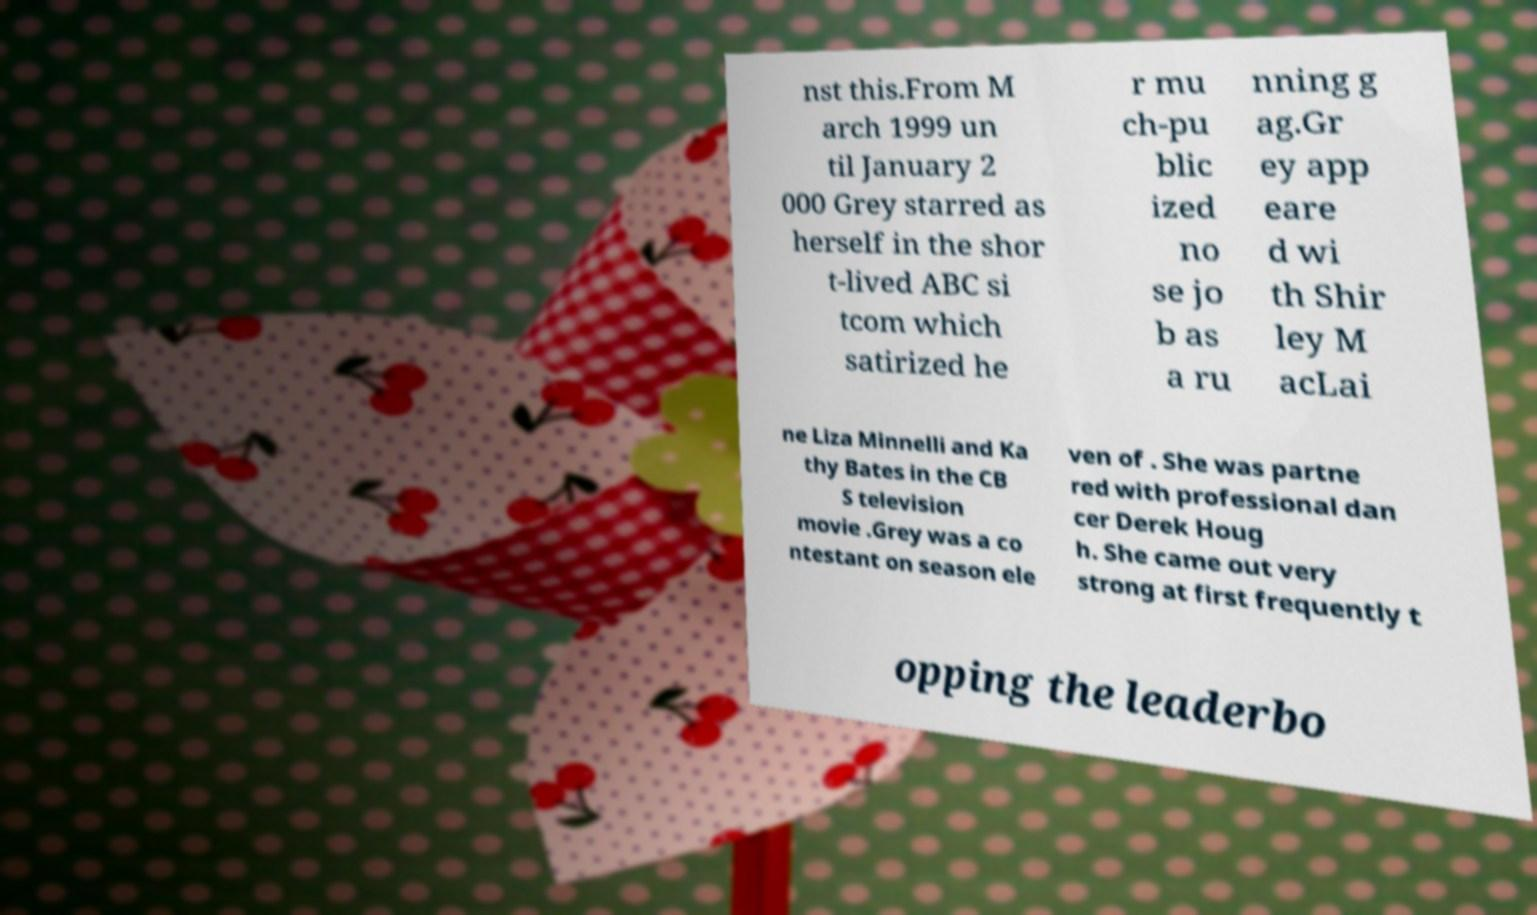For documentation purposes, I need the text within this image transcribed. Could you provide that? nst this.From M arch 1999 un til January 2 000 Grey starred as herself in the shor t-lived ABC si tcom which satirized he r mu ch-pu blic ized no se jo b as a ru nning g ag.Gr ey app eare d wi th Shir ley M acLai ne Liza Minnelli and Ka thy Bates in the CB S television movie .Grey was a co ntestant on season ele ven of . She was partne red with professional dan cer Derek Houg h. She came out very strong at first frequently t opping the leaderbo 